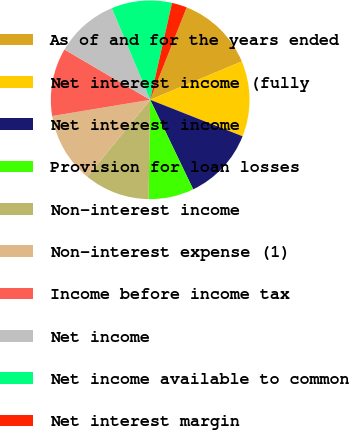Convert chart to OTSL. <chart><loc_0><loc_0><loc_500><loc_500><pie_chart><fcel>As of and for the years ended<fcel>Net interest income (fully<fcel>Net interest income<fcel>Provision for loan losses<fcel>Non-interest income<fcel>Non-interest expense (1)<fcel>Income before income tax<fcel>Net income<fcel>Net income available to common<fcel>Net interest margin<nl><fcel>12.7%<fcel>12.3%<fcel>11.89%<fcel>7.38%<fcel>10.66%<fcel>11.48%<fcel>11.07%<fcel>10.25%<fcel>9.84%<fcel>2.46%<nl></chart> 